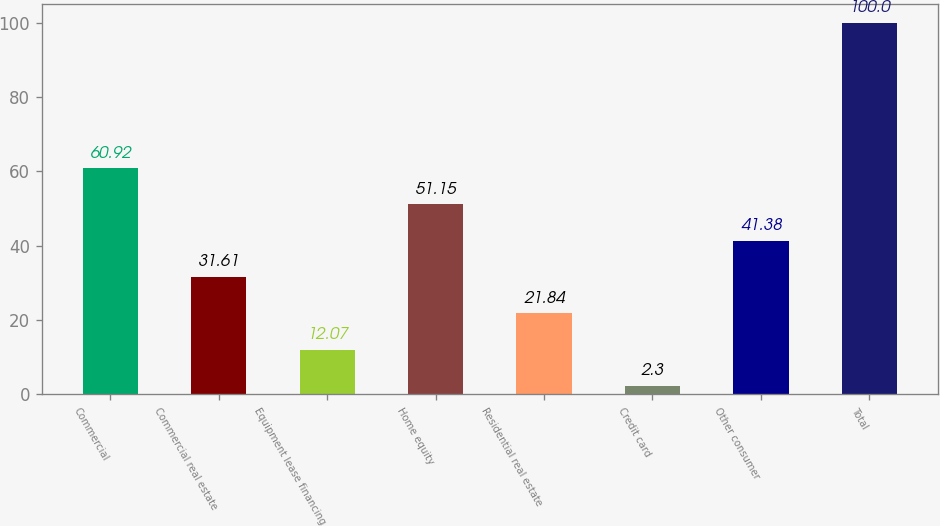Convert chart. <chart><loc_0><loc_0><loc_500><loc_500><bar_chart><fcel>Commercial<fcel>Commercial real estate<fcel>Equipment lease financing<fcel>Home equity<fcel>Residential real estate<fcel>Credit card<fcel>Other consumer<fcel>Total<nl><fcel>60.92<fcel>31.61<fcel>12.07<fcel>51.15<fcel>21.84<fcel>2.3<fcel>41.38<fcel>100<nl></chart> 